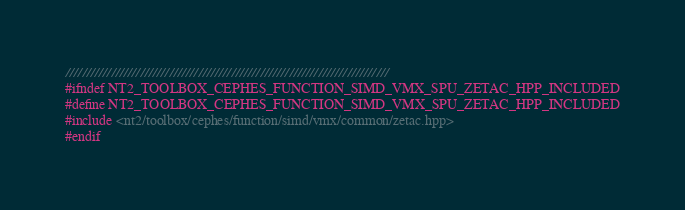<code> <loc_0><loc_0><loc_500><loc_500><_C++_>//////////////////////////////////////////////////////////////////////////////
#ifndef NT2_TOOLBOX_CEPHES_FUNCTION_SIMD_VMX_SPU_ZETAC_HPP_INCLUDED
#define NT2_TOOLBOX_CEPHES_FUNCTION_SIMD_VMX_SPU_ZETAC_HPP_INCLUDED
#include <nt2/toolbox/cephes/function/simd/vmx/common/zetac.hpp>
#endif
</code> 